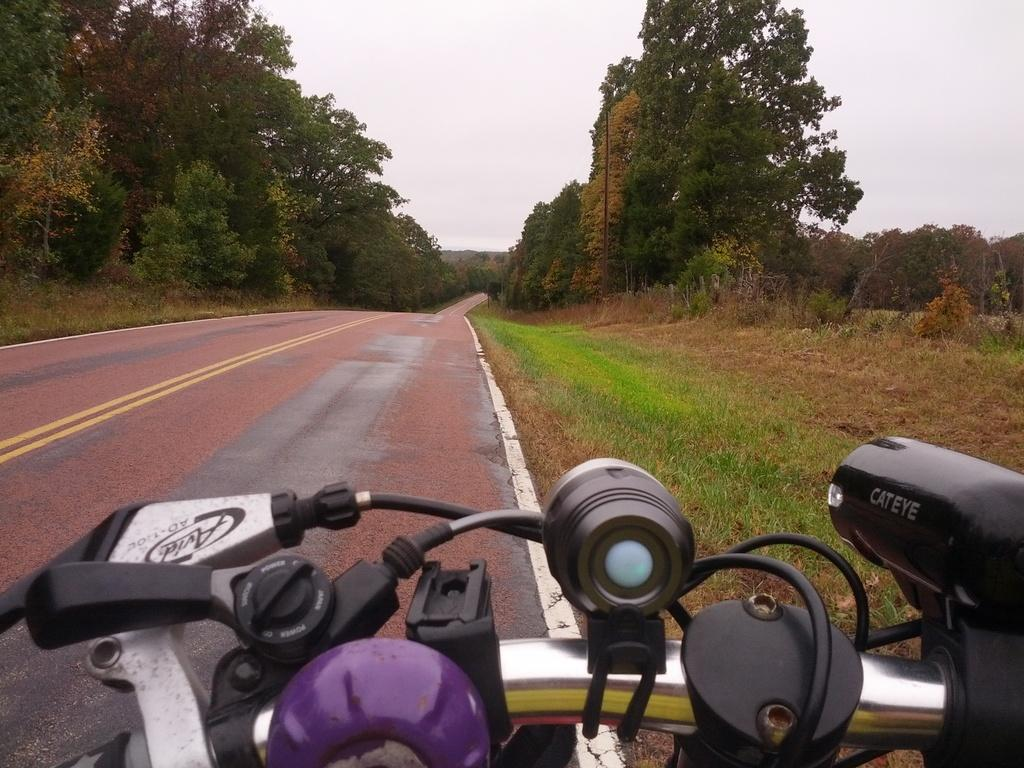What is the main subject in the foreground of the image? There is a vehicle in the foreground of the image. Where is the vehicle located? The vehicle is on the road. What can be seen in the background of the image? There is grass, trees, and the sky visible in the background of the image. What type of representative is standing next to the vehicle in the image? There is no representative present in the image; it only features a vehicle on the road with a background of grass, trees, and the sky. 